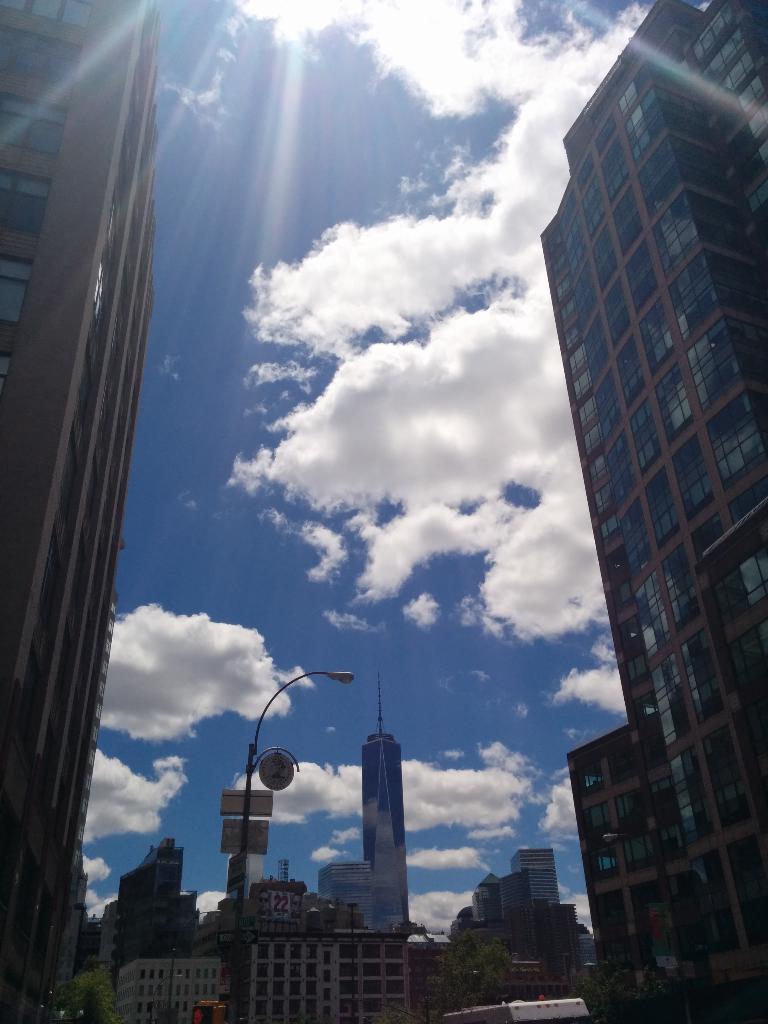Please provide a concise description of this image. In this picture we can see buildings, trees, pole, name boards, some objects and in the background we can see the sky with clouds. 